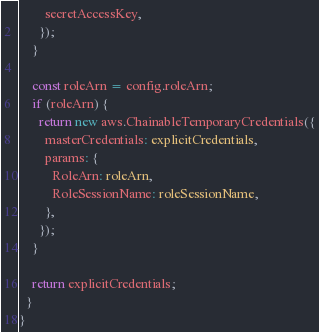Convert code to text. <code><loc_0><loc_0><loc_500><loc_500><_TypeScript_>        secretAccessKey,
      });
    }

    const roleArn = config.roleArn;
    if (roleArn) {
      return new aws.ChainableTemporaryCredentials({
        masterCredentials: explicitCredentials,
        params: {
          RoleArn: roleArn,
          RoleSessionName: roleSessionName,
        },
      });
    }

    return explicitCredentials;
  }
}
</code> 